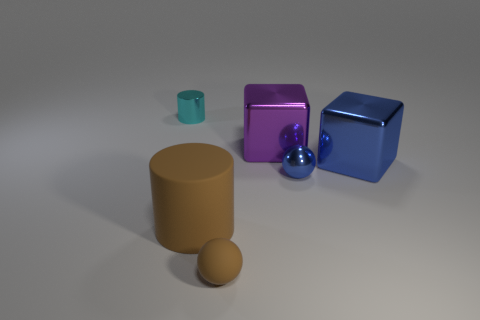Are there any rubber objects that have the same color as the matte cylinder?
Ensure brevity in your answer.  Yes. The rubber thing that is the same color as the rubber sphere is what size?
Ensure brevity in your answer.  Large. What is the material of the tiny ball that is to the left of the big purple object?
Keep it short and to the point. Rubber. What number of blue objects are big rubber cylinders or tiny balls?
Keep it short and to the point. 1. Do the big blue thing and the cylinder in front of the small cyan cylinder have the same material?
Ensure brevity in your answer.  No. Are there an equal number of blue metallic spheres that are in front of the shiny sphere and small cyan cylinders in front of the purple cube?
Give a very brief answer. Yes. Do the brown cylinder and the sphere in front of the large matte cylinder have the same size?
Ensure brevity in your answer.  No. Is the number of tiny brown balls left of the shiny sphere greater than the number of large yellow rubber cubes?
Keep it short and to the point. Yes. What number of cyan cylinders are the same size as the brown ball?
Offer a terse response. 1. There is a sphere that is on the right side of the small brown ball; does it have the same size as the cylinder that is in front of the tiny cylinder?
Provide a short and direct response. No. 